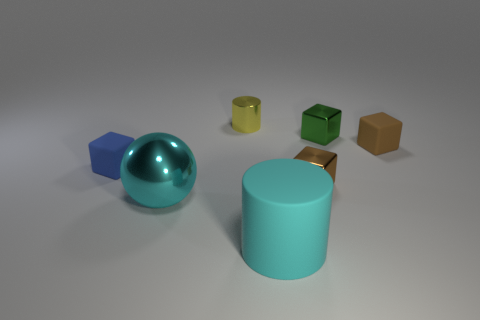Subtract all tiny brown rubber cubes. How many cubes are left? 3 Add 1 small cyan cubes. How many objects exist? 8 Subtract all cylinders. How many objects are left? 5 Subtract 1 cyan cylinders. How many objects are left? 6 Subtract 2 blocks. How many blocks are left? 2 Subtract all cyan cubes. Subtract all cyan cylinders. How many cubes are left? 4 Subtract all green cubes. How many yellow balls are left? 0 Subtract all tiny blue rubber things. Subtract all big cyan matte cylinders. How many objects are left? 5 Add 4 small yellow objects. How many small yellow objects are left? 5 Add 5 yellow metallic things. How many yellow metallic things exist? 6 